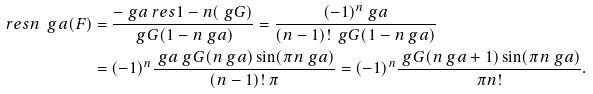Convert formula to latex. <formula><loc_0><loc_0><loc_500><loc_500>\ r e s { n \ g a } ( F ) & = \frac { - \ g a \ r e s { 1 - n } ( \ g G ) } { \ g G ( 1 - n \ g a ) } = \frac { ( - 1 ) ^ { n } \ g a } { ( n - 1 ) ! \, \ g G ( 1 - n \ g a ) } \\ & = ( - 1 ) ^ { n } \frac { \ g a \ g G ( n \ g a ) \sin ( \pi n \ g a ) } { ( n - 1 ) ! \, \pi } = ( - 1 ) ^ { n } \frac { \ g G ( n \ g a + 1 ) \sin ( \pi n \ g a ) } { \pi n ! } .</formula> 